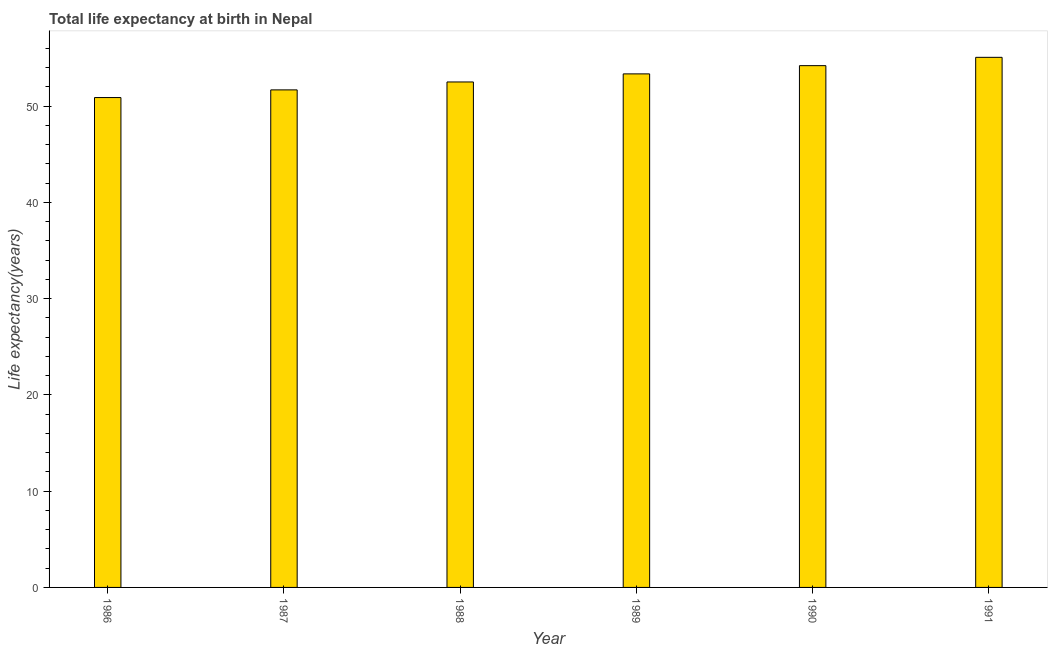Does the graph contain grids?
Make the answer very short. No. What is the title of the graph?
Your response must be concise. Total life expectancy at birth in Nepal. What is the label or title of the X-axis?
Ensure brevity in your answer.  Year. What is the label or title of the Y-axis?
Ensure brevity in your answer.  Life expectancy(years). What is the life expectancy at birth in 1989?
Offer a very short reply. 53.34. Across all years, what is the maximum life expectancy at birth?
Offer a very short reply. 55.06. Across all years, what is the minimum life expectancy at birth?
Offer a terse response. 50.88. What is the sum of the life expectancy at birth?
Your response must be concise. 317.65. What is the difference between the life expectancy at birth in 1986 and 1989?
Offer a terse response. -2.46. What is the average life expectancy at birth per year?
Offer a very short reply. 52.94. What is the median life expectancy at birth?
Ensure brevity in your answer.  52.92. In how many years, is the life expectancy at birth greater than 48 years?
Offer a very short reply. 6. Do a majority of the years between 1986 and 1987 (inclusive) have life expectancy at birth greater than 20 years?
Ensure brevity in your answer.  Yes. What is the ratio of the life expectancy at birth in 1988 to that in 1991?
Keep it short and to the point. 0.95. Is the life expectancy at birth in 1987 less than that in 1990?
Your answer should be compact. Yes. What is the difference between the highest and the second highest life expectancy at birth?
Your answer should be very brief. 0.86. Is the sum of the life expectancy at birth in 1988 and 1991 greater than the maximum life expectancy at birth across all years?
Keep it short and to the point. Yes. What is the difference between the highest and the lowest life expectancy at birth?
Provide a succinct answer. 4.18. How many bars are there?
Your response must be concise. 6. Are all the bars in the graph horizontal?
Your answer should be compact. No. What is the difference between two consecutive major ticks on the Y-axis?
Make the answer very short. 10. Are the values on the major ticks of Y-axis written in scientific E-notation?
Provide a succinct answer. No. What is the Life expectancy(years) of 1986?
Offer a terse response. 50.88. What is the Life expectancy(years) of 1987?
Provide a short and direct response. 51.68. What is the Life expectancy(years) of 1988?
Offer a very short reply. 52.5. What is the Life expectancy(years) in 1989?
Keep it short and to the point. 53.34. What is the Life expectancy(years) of 1990?
Provide a succinct answer. 54.19. What is the Life expectancy(years) of 1991?
Offer a very short reply. 55.06. What is the difference between the Life expectancy(years) in 1986 and 1987?
Your answer should be compact. -0.8. What is the difference between the Life expectancy(years) in 1986 and 1988?
Ensure brevity in your answer.  -1.62. What is the difference between the Life expectancy(years) in 1986 and 1989?
Provide a succinct answer. -2.46. What is the difference between the Life expectancy(years) in 1986 and 1990?
Offer a very short reply. -3.31. What is the difference between the Life expectancy(years) in 1986 and 1991?
Offer a terse response. -4.18. What is the difference between the Life expectancy(years) in 1987 and 1988?
Offer a very short reply. -0.82. What is the difference between the Life expectancy(years) in 1987 and 1989?
Keep it short and to the point. -1.66. What is the difference between the Life expectancy(years) in 1987 and 1990?
Offer a very short reply. -2.52. What is the difference between the Life expectancy(years) in 1987 and 1991?
Offer a terse response. -3.38. What is the difference between the Life expectancy(years) in 1988 and 1989?
Your response must be concise. -0.84. What is the difference between the Life expectancy(years) in 1988 and 1990?
Your answer should be very brief. -1.69. What is the difference between the Life expectancy(years) in 1988 and 1991?
Make the answer very short. -2.56. What is the difference between the Life expectancy(years) in 1989 and 1990?
Provide a short and direct response. -0.86. What is the difference between the Life expectancy(years) in 1989 and 1991?
Provide a short and direct response. -1.72. What is the difference between the Life expectancy(years) in 1990 and 1991?
Make the answer very short. -0.86. What is the ratio of the Life expectancy(years) in 1986 to that in 1987?
Keep it short and to the point. 0.98. What is the ratio of the Life expectancy(years) in 1986 to that in 1989?
Your answer should be compact. 0.95. What is the ratio of the Life expectancy(years) in 1986 to that in 1990?
Keep it short and to the point. 0.94. What is the ratio of the Life expectancy(years) in 1986 to that in 1991?
Offer a very short reply. 0.92. What is the ratio of the Life expectancy(years) in 1987 to that in 1989?
Make the answer very short. 0.97. What is the ratio of the Life expectancy(years) in 1987 to that in 1990?
Provide a succinct answer. 0.95. What is the ratio of the Life expectancy(years) in 1987 to that in 1991?
Offer a very short reply. 0.94. What is the ratio of the Life expectancy(years) in 1988 to that in 1989?
Provide a short and direct response. 0.98. What is the ratio of the Life expectancy(years) in 1988 to that in 1990?
Your answer should be compact. 0.97. What is the ratio of the Life expectancy(years) in 1988 to that in 1991?
Keep it short and to the point. 0.95. What is the ratio of the Life expectancy(years) in 1989 to that in 1990?
Keep it short and to the point. 0.98. What is the ratio of the Life expectancy(years) in 1990 to that in 1991?
Your answer should be compact. 0.98. 